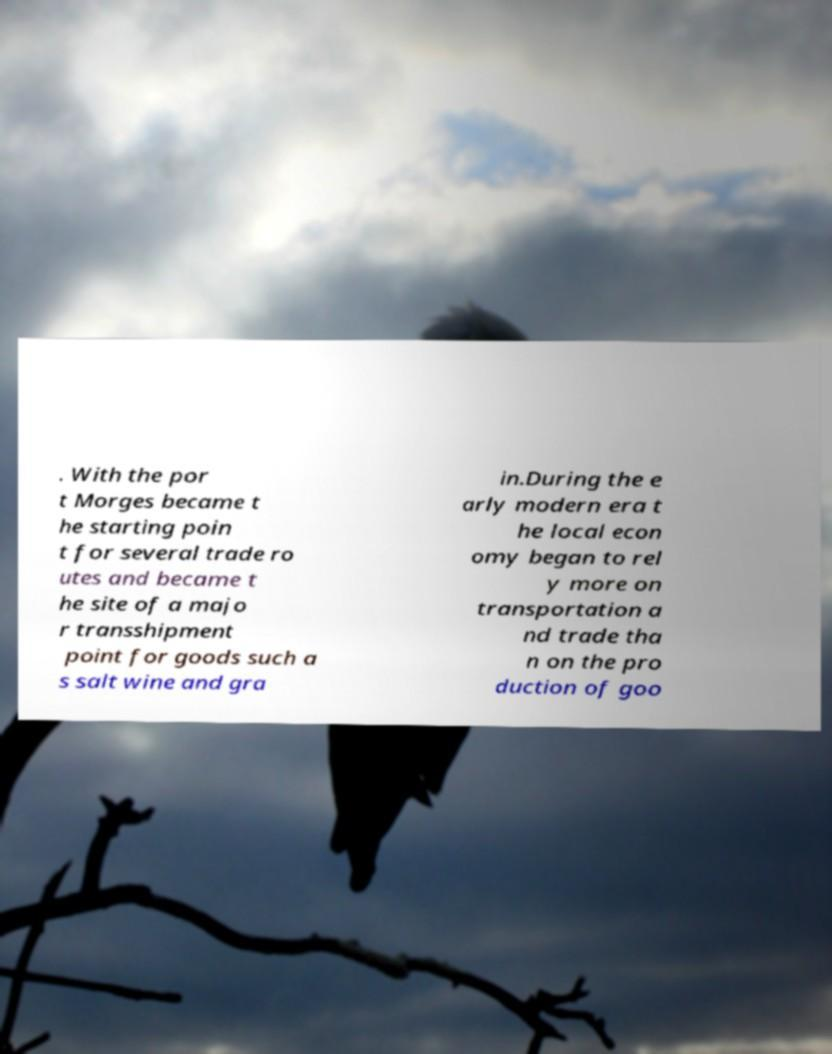Please read and relay the text visible in this image. What does it say? . With the por t Morges became t he starting poin t for several trade ro utes and became t he site of a majo r transshipment point for goods such a s salt wine and gra in.During the e arly modern era t he local econ omy began to rel y more on transportation a nd trade tha n on the pro duction of goo 